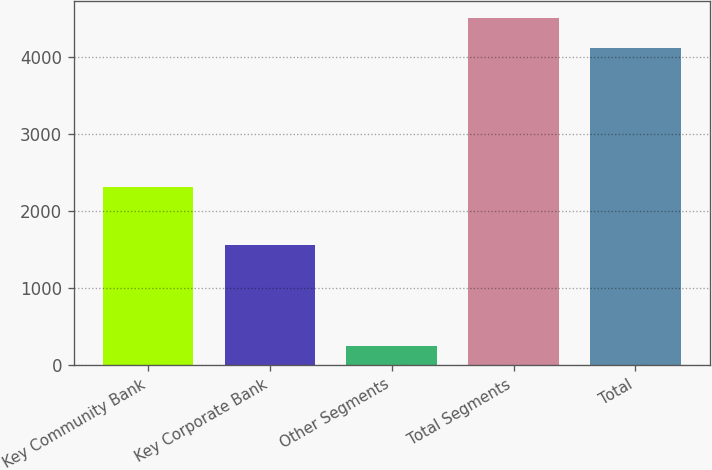Convert chart. <chart><loc_0><loc_0><loc_500><loc_500><bar_chart><fcel>Key Community Bank<fcel>Key Corporate Bank<fcel>Other Segments<fcel>Total Segments<fcel>Total<nl><fcel>2315<fcel>1557<fcel>243<fcel>4501.2<fcel>4114<nl></chart> 